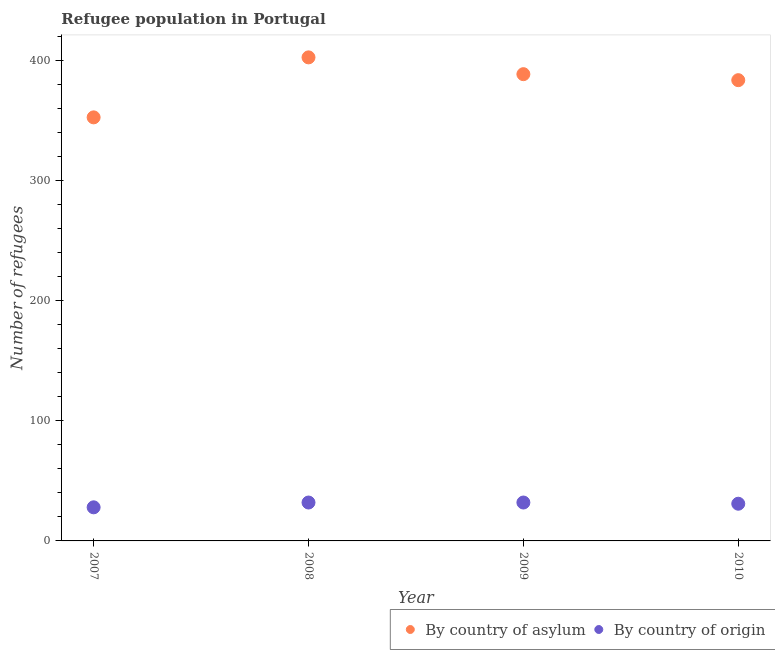Is the number of dotlines equal to the number of legend labels?
Provide a short and direct response. Yes. What is the number of refugees by country of origin in 2009?
Provide a short and direct response. 32. Across all years, what is the maximum number of refugees by country of asylum?
Give a very brief answer. 403. Across all years, what is the minimum number of refugees by country of asylum?
Offer a very short reply. 353. In which year was the number of refugees by country of asylum maximum?
Offer a terse response. 2008. What is the total number of refugees by country of origin in the graph?
Your answer should be compact. 123. What is the difference between the number of refugees by country of asylum in 2007 and that in 2008?
Provide a succinct answer. -50. What is the difference between the number of refugees by country of origin in 2010 and the number of refugees by country of asylum in 2009?
Your answer should be compact. -358. What is the average number of refugees by country of asylum per year?
Your answer should be compact. 382.25. In the year 2007, what is the difference between the number of refugees by country of origin and number of refugees by country of asylum?
Make the answer very short. -325. What is the ratio of the number of refugees by country of origin in 2007 to that in 2009?
Keep it short and to the point. 0.88. Is the difference between the number of refugees by country of asylum in 2008 and 2010 greater than the difference between the number of refugees by country of origin in 2008 and 2010?
Make the answer very short. Yes. What is the difference between the highest and the lowest number of refugees by country of origin?
Your response must be concise. 4. Does the number of refugees by country of asylum monotonically increase over the years?
Ensure brevity in your answer.  No. Is the number of refugees by country of origin strictly less than the number of refugees by country of asylum over the years?
Offer a terse response. Yes. Are the values on the major ticks of Y-axis written in scientific E-notation?
Provide a succinct answer. No. How many legend labels are there?
Give a very brief answer. 2. How are the legend labels stacked?
Provide a succinct answer. Horizontal. What is the title of the graph?
Keep it short and to the point. Refugee population in Portugal. Does "Girls" appear as one of the legend labels in the graph?
Offer a terse response. No. What is the label or title of the X-axis?
Your response must be concise. Year. What is the label or title of the Y-axis?
Offer a very short reply. Number of refugees. What is the Number of refugees in By country of asylum in 2007?
Keep it short and to the point. 353. What is the Number of refugees of By country of asylum in 2008?
Ensure brevity in your answer.  403. What is the Number of refugees of By country of asylum in 2009?
Keep it short and to the point. 389. What is the Number of refugees in By country of origin in 2009?
Your response must be concise. 32. What is the Number of refugees of By country of asylum in 2010?
Ensure brevity in your answer.  384. What is the Number of refugees in By country of origin in 2010?
Your answer should be compact. 31. Across all years, what is the maximum Number of refugees of By country of asylum?
Your response must be concise. 403. Across all years, what is the maximum Number of refugees of By country of origin?
Ensure brevity in your answer.  32. Across all years, what is the minimum Number of refugees in By country of asylum?
Keep it short and to the point. 353. What is the total Number of refugees of By country of asylum in the graph?
Make the answer very short. 1529. What is the total Number of refugees in By country of origin in the graph?
Your answer should be very brief. 123. What is the difference between the Number of refugees in By country of asylum in 2007 and that in 2008?
Offer a very short reply. -50. What is the difference between the Number of refugees of By country of asylum in 2007 and that in 2009?
Provide a succinct answer. -36. What is the difference between the Number of refugees in By country of asylum in 2007 and that in 2010?
Provide a short and direct response. -31. What is the difference between the Number of refugees of By country of origin in 2007 and that in 2010?
Give a very brief answer. -3. What is the difference between the Number of refugees of By country of asylum in 2008 and that in 2009?
Provide a succinct answer. 14. What is the difference between the Number of refugees of By country of asylum in 2009 and that in 2010?
Keep it short and to the point. 5. What is the difference between the Number of refugees in By country of origin in 2009 and that in 2010?
Ensure brevity in your answer.  1. What is the difference between the Number of refugees in By country of asylum in 2007 and the Number of refugees in By country of origin in 2008?
Offer a terse response. 321. What is the difference between the Number of refugees in By country of asylum in 2007 and the Number of refugees in By country of origin in 2009?
Keep it short and to the point. 321. What is the difference between the Number of refugees in By country of asylum in 2007 and the Number of refugees in By country of origin in 2010?
Your answer should be compact. 322. What is the difference between the Number of refugees in By country of asylum in 2008 and the Number of refugees in By country of origin in 2009?
Your response must be concise. 371. What is the difference between the Number of refugees of By country of asylum in 2008 and the Number of refugees of By country of origin in 2010?
Provide a succinct answer. 372. What is the difference between the Number of refugees in By country of asylum in 2009 and the Number of refugees in By country of origin in 2010?
Provide a short and direct response. 358. What is the average Number of refugees in By country of asylum per year?
Your response must be concise. 382.25. What is the average Number of refugees of By country of origin per year?
Your answer should be very brief. 30.75. In the year 2007, what is the difference between the Number of refugees of By country of asylum and Number of refugees of By country of origin?
Offer a very short reply. 325. In the year 2008, what is the difference between the Number of refugees of By country of asylum and Number of refugees of By country of origin?
Your answer should be compact. 371. In the year 2009, what is the difference between the Number of refugees in By country of asylum and Number of refugees in By country of origin?
Provide a succinct answer. 357. In the year 2010, what is the difference between the Number of refugees in By country of asylum and Number of refugees in By country of origin?
Ensure brevity in your answer.  353. What is the ratio of the Number of refugees in By country of asylum in 2007 to that in 2008?
Offer a very short reply. 0.88. What is the ratio of the Number of refugees of By country of asylum in 2007 to that in 2009?
Give a very brief answer. 0.91. What is the ratio of the Number of refugees of By country of origin in 2007 to that in 2009?
Your response must be concise. 0.88. What is the ratio of the Number of refugees of By country of asylum in 2007 to that in 2010?
Ensure brevity in your answer.  0.92. What is the ratio of the Number of refugees of By country of origin in 2007 to that in 2010?
Ensure brevity in your answer.  0.9. What is the ratio of the Number of refugees in By country of asylum in 2008 to that in 2009?
Provide a short and direct response. 1.04. What is the ratio of the Number of refugees of By country of origin in 2008 to that in 2009?
Your answer should be very brief. 1. What is the ratio of the Number of refugees of By country of asylum in 2008 to that in 2010?
Give a very brief answer. 1.05. What is the ratio of the Number of refugees of By country of origin in 2008 to that in 2010?
Give a very brief answer. 1.03. What is the ratio of the Number of refugees of By country of asylum in 2009 to that in 2010?
Offer a very short reply. 1.01. What is the ratio of the Number of refugees in By country of origin in 2009 to that in 2010?
Your answer should be compact. 1.03. What is the difference between the highest and the second highest Number of refugees of By country of asylum?
Your answer should be very brief. 14. What is the difference between the highest and the lowest Number of refugees in By country of asylum?
Keep it short and to the point. 50. 